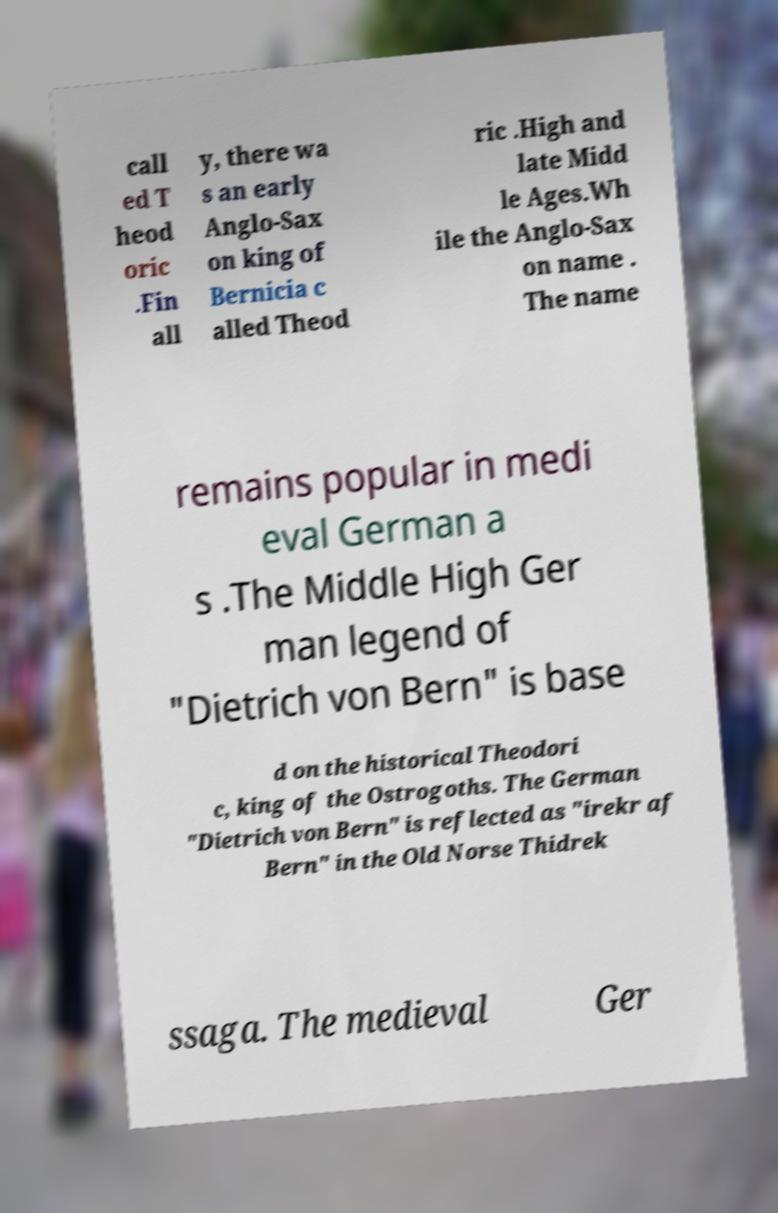Could you assist in decoding the text presented in this image and type it out clearly? call ed T heod oric .Fin all y, there wa s an early Anglo-Sax on king of Bernicia c alled Theod ric .High and late Midd le Ages.Wh ile the Anglo-Sax on name . The name remains popular in medi eval German a s .The Middle High Ger man legend of "Dietrich von Bern" is base d on the historical Theodori c, king of the Ostrogoths. The German "Dietrich von Bern" is reflected as "irekr af Bern" in the Old Norse Thidrek ssaga. The medieval Ger 